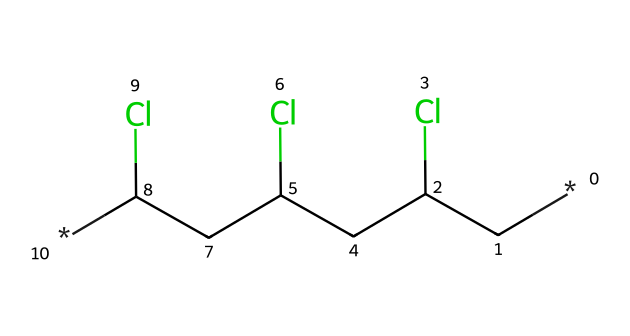What is the core structural repeating unit in this chemical? The chemical structure indicates that the core repeating unit involves vinyl groups (with chlorine substitutions), typically referred to as the polyvinyl group.
Answer: polyvinyl group How many chlorine atoms are present in this compound? By analyzing the structure, there are three chlorine atoms attached to the carbon chain, which are evident in the SMILES representation.
Answer: three What type of polymer is represented by this chemical structure? Given that it contains repeating units derived from vinyl, it is classified as a vinyl polymer, specifically polyvinyl chloride (PVC).
Answer: vinyl polymer What is the primary use of this polymer in construction? The primary application of polyvinyl chloride (PVC) in construction is for plumbing pipes and fittings, due to its durability and resistance to corrosion.
Answer: plumbing pipes How does the presence of chlorine affect the properties of this polymer? The chlorine atoms increase the polymer's density and make it more resistant to fire, also affecting its overall stability and resistance to chemical agents.
Answer: increases stability What is the primary method of synthesizing this polymer? The primary method for synthesizing polyvinyl chloride is through the polymerization of vinyl chloride monomers, typically via free-radical polymerization.
Answer: polymerization 